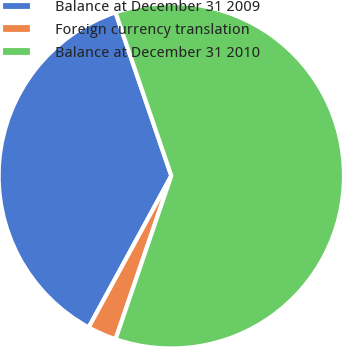Convert chart to OTSL. <chart><loc_0><loc_0><loc_500><loc_500><pie_chart><fcel>Balance at December 31 2009<fcel>Foreign currency translation<fcel>Balance at December 31 2010<nl><fcel>36.82%<fcel>2.71%<fcel>60.47%<nl></chart> 